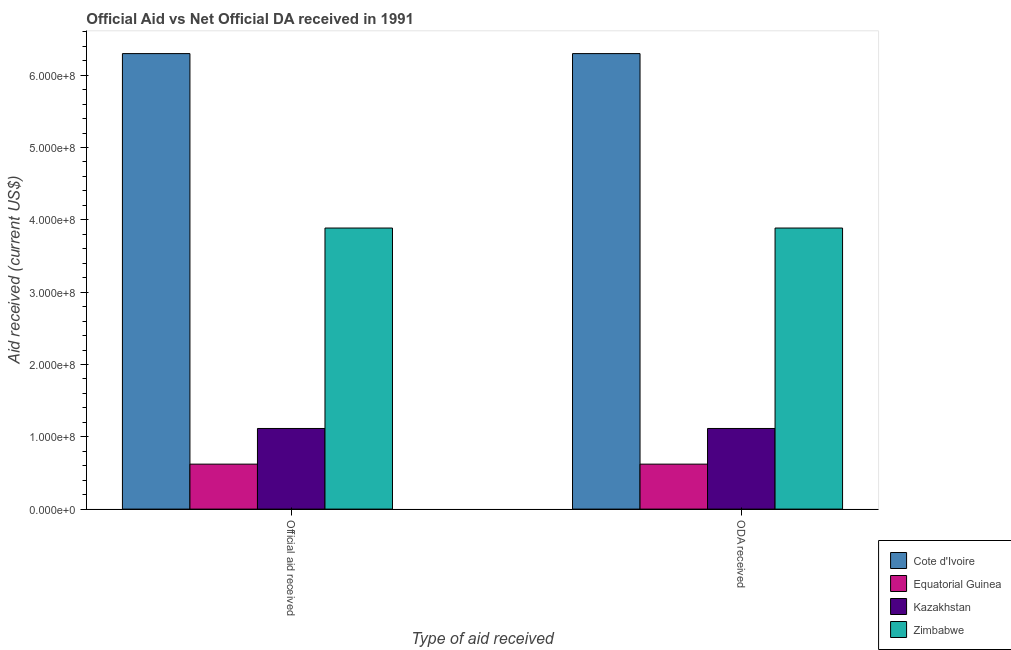How many different coloured bars are there?
Ensure brevity in your answer.  4. Are the number of bars per tick equal to the number of legend labels?
Provide a short and direct response. Yes. Are the number of bars on each tick of the X-axis equal?
Offer a very short reply. Yes. What is the label of the 2nd group of bars from the left?
Make the answer very short. ODA received. What is the official aid received in Kazakhstan?
Keep it short and to the point. 1.12e+08. Across all countries, what is the maximum oda received?
Offer a terse response. 6.30e+08. Across all countries, what is the minimum oda received?
Keep it short and to the point. 6.22e+07. In which country was the official aid received maximum?
Offer a terse response. Cote d'Ivoire. In which country was the official aid received minimum?
Ensure brevity in your answer.  Equatorial Guinea. What is the total official aid received in the graph?
Offer a very short reply. 1.19e+09. What is the difference between the oda received in Equatorial Guinea and that in Kazakhstan?
Provide a short and direct response. -4.93e+07. What is the difference between the oda received in Equatorial Guinea and the official aid received in Cote d'Ivoire?
Provide a succinct answer. -5.68e+08. What is the average oda received per country?
Give a very brief answer. 2.98e+08. What is the ratio of the oda received in Zimbabwe to that in Equatorial Guinea?
Your answer should be compact. 6.25. Is the official aid received in Kazakhstan less than that in Cote d'Ivoire?
Provide a short and direct response. Yes. What does the 3rd bar from the left in ODA received represents?
Offer a very short reply. Kazakhstan. What does the 1st bar from the right in Official aid received represents?
Provide a short and direct response. Zimbabwe. How many bars are there?
Give a very brief answer. 8. Are all the bars in the graph horizontal?
Give a very brief answer. No. How many countries are there in the graph?
Offer a very short reply. 4. Are the values on the major ticks of Y-axis written in scientific E-notation?
Offer a terse response. Yes. Does the graph contain any zero values?
Offer a very short reply. No. How are the legend labels stacked?
Your response must be concise. Vertical. What is the title of the graph?
Make the answer very short. Official Aid vs Net Official DA received in 1991 . What is the label or title of the X-axis?
Offer a terse response. Type of aid received. What is the label or title of the Y-axis?
Give a very brief answer. Aid received (current US$). What is the Aid received (current US$) of Cote d'Ivoire in Official aid received?
Make the answer very short. 6.30e+08. What is the Aid received (current US$) in Equatorial Guinea in Official aid received?
Give a very brief answer. 6.22e+07. What is the Aid received (current US$) in Kazakhstan in Official aid received?
Provide a short and direct response. 1.12e+08. What is the Aid received (current US$) in Zimbabwe in Official aid received?
Your answer should be compact. 3.89e+08. What is the Aid received (current US$) in Cote d'Ivoire in ODA received?
Give a very brief answer. 6.30e+08. What is the Aid received (current US$) of Equatorial Guinea in ODA received?
Provide a short and direct response. 6.22e+07. What is the Aid received (current US$) in Kazakhstan in ODA received?
Offer a terse response. 1.12e+08. What is the Aid received (current US$) of Zimbabwe in ODA received?
Your answer should be compact. 3.89e+08. Across all Type of aid received, what is the maximum Aid received (current US$) in Cote d'Ivoire?
Provide a short and direct response. 6.30e+08. Across all Type of aid received, what is the maximum Aid received (current US$) of Equatorial Guinea?
Provide a short and direct response. 6.22e+07. Across all Type of aid received, what is the maximum Aid received (current US$) of Kazakhstan?
Provide a short and direct response. 1.12e+08. Across all Type of aid received, what is the maximum Aid received (current US$) in Zimbabwe?
Offer a terse response. 3.89e+08. Across all Type of aid received, what is the minimum Aid received (current US$) of Cote d'Ivoire?
Keep it short and to the point. 6.30e+08. Across all Type of aid received, what is the minimum Aid received (current US$) of Equatorial Guinea?
Your answer should be compact. 6.22e+07. Across all Type of aid received, what is the minimum Aid received (current US$) of Kazakhstan?
Make the answer very short. 1.12e+08. Across all Type of aid received, what is the minimum Aid received (current US$) in Zimbabwe?
Ensure brevity in your answer.  3.89e+08. What is the total Aid received (current US$) in Cote d'Ivoire in the graph?
Your answer should be very brief. 1.26e+09. What is the total Aid received (current US$) in Equatorial Guinea in the graph?
Provide a succinct answer. 1.24e+08. What is the total Aid received (current US$) of Kazakhstan in the graph?
Keep it short and to the point. 2.23e+08. What is the total Aid received (current US$) of Zimbabwe in the graph?
Offer a terse response. 7.77e+08. What is the difference between the Aid received (current US$) in Cote d'Ivoire in Official aid received and that in ODA received?
Offer a very short reply. 0. What is the difference between the Aid received (current US$) in Cote d'Ivoire in Official aid received and the Aid received (current US$) in Equatorial Guinea in ODA received?
Provide a short and direct response. 5.68e+08. What is the difference between the Aid received (current US$) in Cote d'Ivoire in Official aid received and the Aid received (current US$) in Kazakhstan in ODA received?
Make the answer very short. 5.18e+08. What is the difference between the Aid received (current US$) of Cote d'Ivoire in Official aid received and the Aid received (current US$) of Zimbabwe in ODA received?
Your response must be concise. 2.41e+08. What is the difference between the Aid received (current US$) in Equatorial Guinea in Official aid received and the Aid received (current US$) in Kazakhstan in ODA received?
Ensure brevity in your answer.  -4.93e+07. What is the difference between the Aid received (current US$) of Equatorial Guinea in Official aid received and the Aid received (current US$) of Zimbabwe in ODA received?
Provide a succinct answer. -3.26e+08. What is the difference between the Aid received (current US$) in Kazakhstan in Official aid received and the Aid received (current US$) in Zimbabwe in ODA received?
Offer a terse response. -2.77e+08. What is the average Aid received (current US$) of Cote d'Ivoire per Type of aid received?
Offer a terse response. 6.30e+08. What is the average Aid received (current US$) of Equatorial Guinea per Type of aid received?
Your answer should be compact. 6.22e+07. What is the average Aid received (current US$) in Kazakhstan per Type of aid received?
Provide a succinct answer. 1.12e+08. What is the average Aid received (current US$) in Zimbabwe per Type of aid received?
Offer a terse response. 3.89e+08. What is the difference between the Aid received (current US$) in Cote d'Ivoire and Aid received (current US$) in Equatorial Guinea in Official aid received?
Your answer should be very brief. 5.68e+08. What is the difference between the Aid received (current US$) of Cote d'Ivoire and Aid received (current US$) of Kazakhstan in Official aid received?
Give a very brief answer. 5.18e+08. What is the difference between the Aid received (current US$) of Cote d'Ivoire and Aid received (current US$) of Zimbabwe in Official aid received?
Offer a terse response. 2.41e+08. What is the difference between the Aid received (current US$) of Equatorial Guinea and Aid received (current US$) of Kazakhstan in Official aid received?
Provide a succinct answer. -4.93e+07. What is the difference between the Aid received (current US$) of Equatorial Guinea and Aid received (current US$) of Zimbabwe in Official aid received?
Your answer should be very brief. -3.26e+08. What is the difference between the Aid received (current US$) in Kazakhstan and Aid received (current US$) in Zimbabwe in Official aid received?
Offer a terse response. -2.77e+08. What is the difference between the Aid received (current US$) of Cote d'Ivoire and Aid received (current US$) of Equatorial Guinea in ODA received?
Provide a succinct answer. 5.68e+08. What is the difference between the Aid received (current US$) in Cote d'Ivoire and Aid received (current US$) in Kazakhstan in ODA received?
Offer a terse response. 5.18e+08. What is the difference between the Aid received (current US$) in Cote d'Ivoire and Aid received (current US$) in Zimbabwe in ODA received?
Your response must be concise. 2.41e+08. What is the difference between the Aid received (current US$) in Equatorial Guinea and Aid received (current US$) in Kazakhstan in ODA received?
Your answer should be very brief. -4.93e+07. What is the difference between the Aid received (current US$) of Equatorial Guinea and Aid received (current US$) of Zimbabwe in ODA received?
Make the answer very short. -3.26e+08. What is the difference between the Aid received (current US$) of Kazakhstan and Aid received (current US$) of Zimbabwe in ODA received?
Ensure brevity in your answer.  -2.77e+08. What is the ratio of the Aid received (current US$) in Cote d'Ivoire in Official aid received to that in ODA received?
Ensure brevity in your answer.  1. What is the ratio of the Aid received (current US$) in Equatorial Guinea in Official aid received to that in ODA received?
Provide a short and direct response. 1. What is the ratio of the Aid received (current US$) of Kazakhstan in Official aid received to that in ODA received?
Ensure brevity in your answer.  1. What is the difference between the highest and the second highest Aid received (current US$) of Cote d'Ivoire?
Make the answer very short. 0. What is the difference between the highest and the second highest Aid received (current US$) in Equatorial Guinea?
Your response must be concise. 0. What is the difference between the highest and the second highest Aid received (current US$) in Zimbabwe?
Give a very brief answer. 0. What is the difference between the highest and the lowest Aid received (current US$) in Cote d'Ivoire?
Provide a succinct answer. 0. What is the difference between the highest and the lowest Aid received (current US$) in Equatorial Guinea?
Provide a succinct answer. 0. 